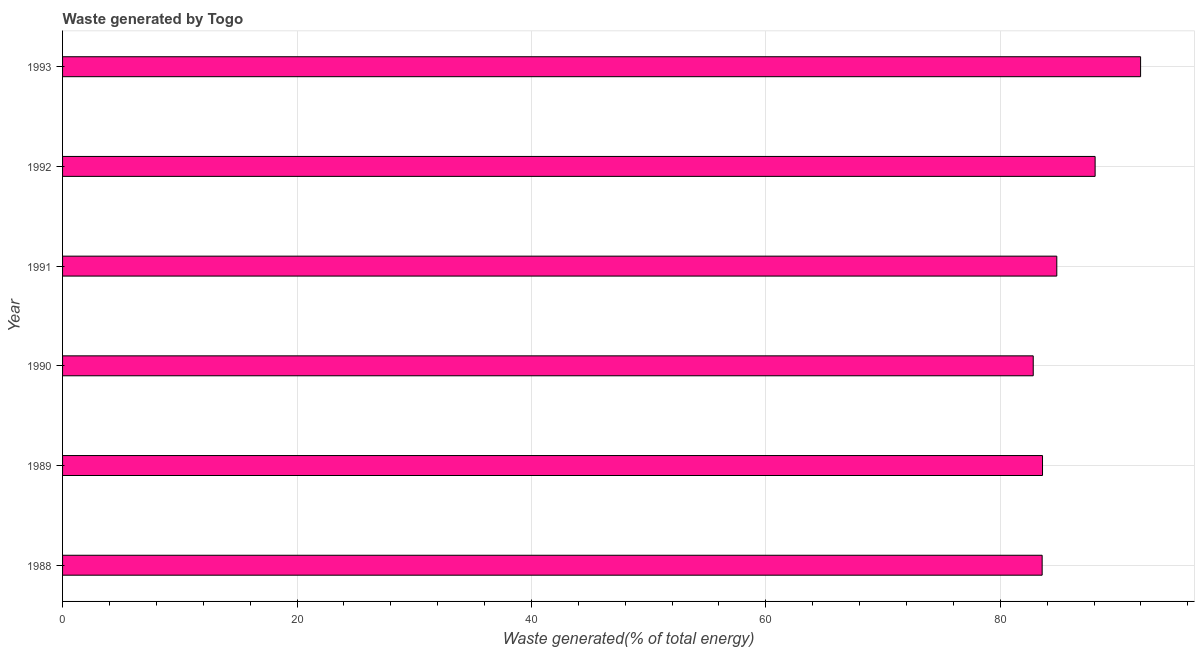Does the graph contain grids?
Your response must be concise. Yes. What is the title of the graph?
Give a very brief answer. Waste generated by Togo. What is the label or title of the X-axis?
Ensure brevity in your answer.  Waste generated(% of total energy). What is the amount of waste generated in 1992?
Ensure brevity in your answer.  88.09. Across all years, what is the maximum amount of waste generated?
Ensure brevity in your answer.  91.97. Across all years, what is the minimum amount of waste generated?
Offer a terse response. 82.81. In which year was the amount of waste generated maximum?
Make the answer very short. 1993. In which year was the amount of waste generated minimum?
Provide a short and direct response. 1990. What is the sum of the amount of waste generated?
Make the answer very short. 514.85. What is the difference between the amount of waste generated in 1989 and 1990?
Keep it short and to the point. 0.79. What is the average amount of waste generated per year?
Offer a terse response. 85.81. What is the median amount of waste generated?
Provide a short and direct response. 84.21. In how many years, is the amount of waste generated greater than 44 %?
Offer a very short reply. 6. Do a majority of the years between 1991 and 1990 (inclusive) have amount of waste generated greater than 40 %?
Offer a terse response. No. What is the difference between the highest and the second highest amount of waste generated?
Ensure brevity in your answer.  3.88. What is the difference between the highest and the lowest amount of waste generated?
Give a very brief answer. 9.16. In how many years, is the amount of waste generated greater than the average amount of waste generated taken over all years?
Offer a very short reply. 2. How many bars are there?
Your answer should be very brief. 6. How many years are there in the graph?
Make the answer very short. 6. What is the Waste generated(% of total energy) in 1988?
Offer a terse response. 83.57. What is the Waste generated(% of total energy) of 1989?
Offer a very short reply. 83.6. What is the Waste generated(% of total energy) of 1990?
Your answer should be very brief. 82.81. What is the Waste generated(% of total energy) in 1991?
Offer a terse response. 84.82. What is the Waste generated(% of total energy) of 1992?
Give a very brief answer. 88.09. What is the Waste generated(% of total energy) in 1993?
Give a very brief answer. 91.97. What is the difference between the Waste generated(% of total energy) in 1988 and 1989?
Give a very brief answer. -0.03. What is the difference between the Waste generated(% of total energy) in 1988 and 1990?
Ensure brevity in your answer.  0.76. What is the difference between the Waste generated(% of total energy) in 1988 and 1991?
Provide a succinct answer. -1.25. What is the difference between the Waste generated(% of total energy) in 1988 and 1992?
Your answer should be very brief. -4.52. What is the difference between the Waste generated(% of total energy) in 1988 and 1993?
Provide a short and direct response. -8.4. What is the difference between the Waste generated(% of total energy) in 1989 and 1990?
Your answer should be compact. 0.79. What is the difference between the Waste generated(% of total energy) in 1989 and 1991?
Provide a succinct answer. -1.22. What is the difference between the Waste generated(% of total energy) in 1989 and 1992?
Provide a succinct answer. -4.49. What is the difference between the Waste generated(% of total energy) in 1989 and 1993?
Provide a succinct answer. -8.37. What is the difference between the Waste generated(% of total energy) in 1990 and 1991?
Make the answer very short. -2.01. What is the difference between the Waste generated(% of total energy) in 1990 and 1992?
Offer a terse response. -5.28. What is the difference between the Waste generated(% of total energy) in 1990 and 1993?
Keep it short and to the point. -9.16. What is the difference between the Waste generated(% of total energy) in 1991 and 1992?
Offer a terse response. -3.27. What is the difference between the Waste generated(% of total energy) in 1991 and 1993?
Provide a succinct answer. -7.15. What is the difference between the Waste generated(% of total energy) in 1992 and 1993?
Provide a succinct answer. -3.88. What is the ratio of the Waste generated(% of total energy) in 1988 to that in 1989?
Give a very brief answer. 1. What is the ratio of the Waste generated(% of total energy) in 1988 to that in 1990?
Offer a very short reply. 1.01. What is the ratio of the Waste generated(% of total energy) in 1988 to that in 1991?
Your answer should be very brief. 0.98. What is the ratio of the Waste generated(% of total energy) in 1988 to that in 1992?
Provide a succinct answer. 0.95. What is the ratio of the Waste generated(% of total energy) in 1988 to that in 1993?
Provide a succinct answer. 0.91. What is the ratio of the Waste generated(% of total energy) in 1989 to that in 1990?
Give a very brief answer. 1.01. What is the ratio of the Waste generated(% of total energy) in 1989 to that in 1992?
Keep it short and to the point. 0.95. What is the ratio of the Waste generated(% of total energy) in 1989 to that in 1993?
Your answer should be very brief. 0.91. What is the ratio of the Waste generated(% of total energy) in 1990 to that in 1991?
Your response must be concise. 0.98. What is the ratio of the Waste generated(% of total energy) in 1990 to that in 1993?
Give a very brief answer. 0.9. What is the ratio of the Waste generated(% of total energy) in 1991 to that in 1992?
Provide a short and direct response. 0.96. What is the ratio of the Waste generated(% of total energy) in 1991 to that in 1993?
Your answer should be very brief. 0.92. What is the ratio of the Waste generated(% of total energy) in 1992 to that in 1993?
Give a very brief answer. 0.96. 